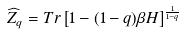Convert formula to latex. <formula><loc_0><loc_0><loc_500><loc_500>\widehat { Z } _ { q } = T r \left [ 1 - ( 1 - q ) \beta H \right ] ^ { \frac { 1 } { 1 - q } }</formula> 